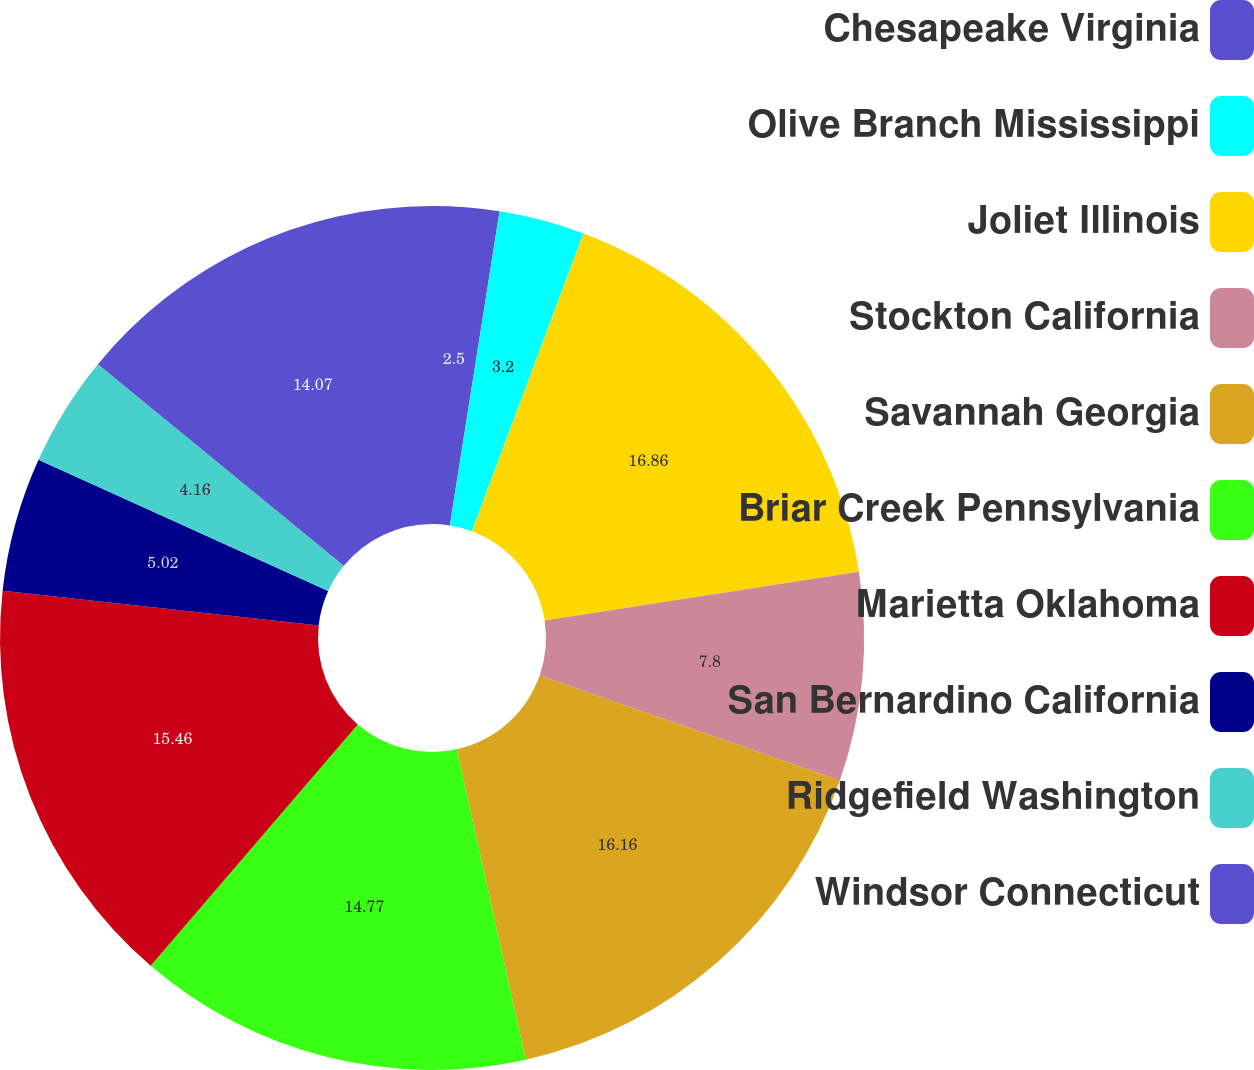Convert chart to OTSL. <chart><loc_0><loc_0><loc_500><loc_500><pie_chart><fcel>Chesapeake Virginia<fcel>Olive Branch Mississippi<fcel>Joliet Illinois<fcel>Stockton California<fcel>Savannah Georgia<fcel>Briar Creek Pennsylvania<fcel>Marietta Oklahoma<fcel>San Bernardino California<fcel>Ridgefield Washington<fcel>Windsor Connecticut<nl><fcel>2.5%<fcel>3.2%<fcel>16.85%<fcel>7.8%<fcel>16.16%<fcel>14.77%<fcel>15.46%<fcel>5.02%<fcel>4.16%<fcel>14.07%<nl></chart> 